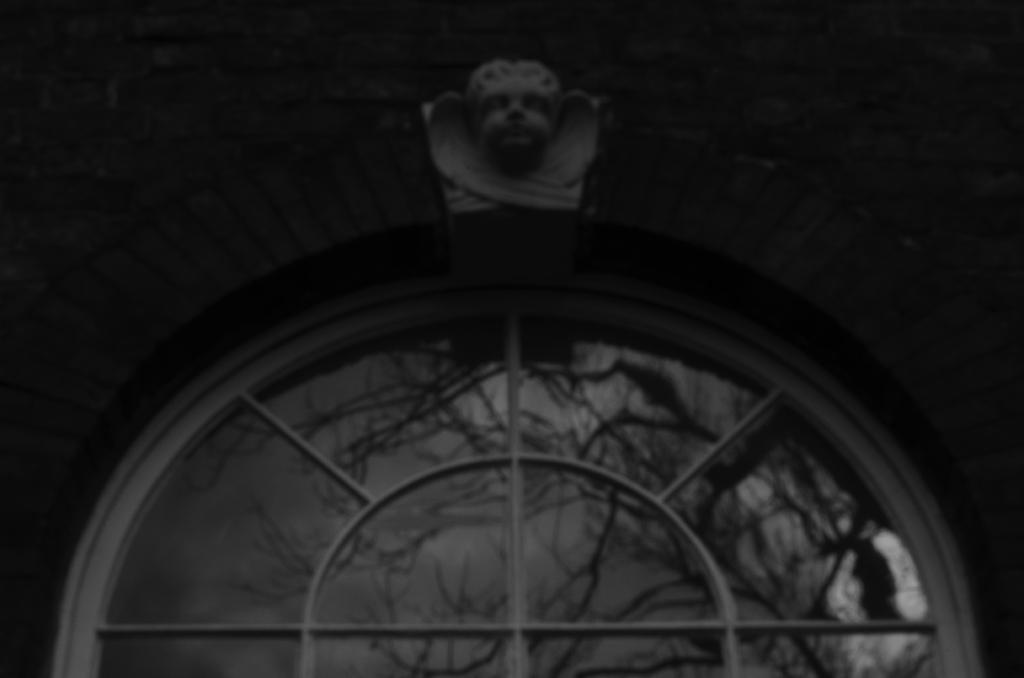What is present on the wall in the image? There is a sculpture on the wall in the image. What else can be seen on the wall besides the sculpture? There is a window with a glass below the sculpture on the wall. Can you describe the window in the image? The window has a glass and is located below the sculpture on the wall. Is there a calendar hanging next to the sculpture on the wall? There is no mention of a calendar in the provided facts, so we cannot determine if there is one present in the image. 